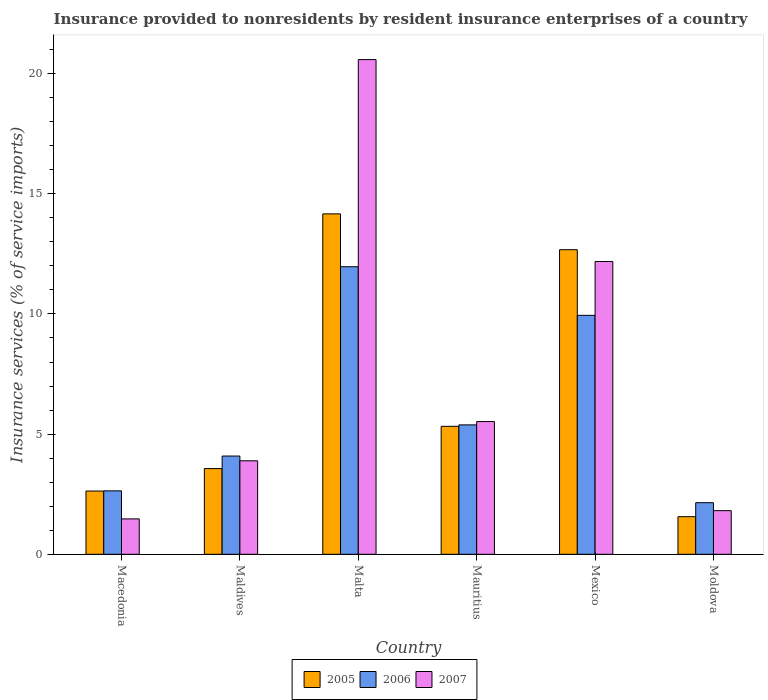How many different coloured bars are there?
Your answer should be compact. 3. Are the number of bars on each tick of the X-axis equal?
Your response must be concise. Yes. How many bars are there on the 4th tick from the left?
Your answer should be compact. 3. What is the label of the 2nd group of bars from the left?
Offer a very short reply. Maldives. In how many cases, is the number of bars for a given country not equal to the number of legend labels?
Provide a succinct answer. 0. What is the insurance provided to nonresidents in 2007 in Maldives?
Offer a very short reply. 3.89. Across all countries, what is the maximum insurance provided to nonresidents in 2007?
Give a very brief answer. 20.58. Across all countries, what is the minimum insurance provided to nonresidents in 2006?
Your answer should be compact. 2.15. In which country was the insurance provided to nonresidents in 2006 maximum?
Offer a very short reply. Malta. In which country was the insurance provided to nonresidents in 2006 minimum?
Offer a very short reply. Moldova. What is the total insurance provided to nonresidents in 2005 in the graph?
Ensure brevity in your answer.  39.92. What is the difference between the insurance provided to nonresidents in 2007 in Maldives and that in Mauritius?
Keep it short and to the point. -1.63. What is the difference between the insurance provided to nonresidents in 2007 in Mauritius and the insurance provided to nonresidents in 2006 in Moldova?
Give a very brief answer. 3.38. What is the average insurance provided to nonresidents in 2005 per country?
Provide a succinct answer. 6.65. What is the difference between the insurance provided to nonresidents of/in 2005 and insurance provided to nonresidents of/in 2007 in Malta?
Offer a terse response. -6.42. In how many countries, is the insurance provided to nonresidents in 2005 greater than 14 %?
Make the answer very short. 1. What is the ratio of the insurance provided to nonresidents in 2005 in Malta to that in Mauritius?
Offer a terse response. 2.66. Is the insurance provided to nonresidents in 2005 in Mauritius less than that in Moldova?
Keep it short and to the point. No. What is the difference between the highest and the second highest insurance provided to nonresidents in 2005?
Your response must be concise. 7.35. What is the difference between the highest and the lowest insurance provided to nonresidents in 2007?
Offer a very short reply. 19.11. In how many countries, is the insurance provided to nonresidents in 2007 greater than the average insurance provided to nonresidents in 2007 taken over all countries?
Provide a short and direct response. 2. Is the sum of the insurance provided to nonresidents in 2005 in Macedonia and Mauritius greater than the maximum insurance provided to nonresidents in 2007 across all countries?
Give a very brief answer. No. What does the 3rd bar from the left in Mexico represents?
Provide a short and direct response. 2007. What does the 2nd bar from the right in Maldives represents?
Your answer should be very brief. 2006. How many countries are there in the graph?
Your answer should be very brief. 6. How are the legend labels stacked?
Your answer should be very brief. Horizontal. What is the title of the graph?
Your response must be concise. Insurance provided to nonresidents by resident insurance enterprises of a country. What is the label or title of the Y-axis?
Provide a succinct answer. Insurance services (% of service imports). What is the Insurance services (% of service imports) of 2005 in Macedonia?
Your answer should be compact. 2.63. What is the Insurance services (% of service imports) in 2006 in Macedonia?
Provide a succinct answer. 2.64. What is the Insurance services (% of service imports) of 2007 in Macedonia?
Provide a succinct answer. 1.47. What is the Insurance services (% of service imports) in 2005 in Maldives?
Provide a succinct answer. 3.57. What is the Insurance services (% of service imports) of 2006 in Maldives?
Give a very brief answer. 4.09. What is the Insurance services (% of service imports) of 2007 in Maldives?
Provide a short and direct response. 3.89. What is the Insurance services (% of service imports) in 2005 in Malta?
Provide a succinct answer. 14.16. What is the Insurance services (% of service imports) in 2006 in Malta?
Offer a terse response. 11.96. What is the Insurance services (% of service imports) of 2007 in Malta?
Keep it short and to the point. 20.58. What is the Insurance services (% of service imports) in 2005 in Mauritius?
Offer a terse response. 5.32. What is the Insurance services (% of service imports) in 2006 in Mauritius?
Offer a very short reply. 5.38. What is the Insurance services (% of service imports) of 2007 in Mauritius?
Provide a short and direct response. 5.52. What is the Insurance services (% of service imports) of 2005 in Mexico?
Your answer should be compact. 12.67. What is the Insurance services (% of service imports) of 2006 in Mexico?
Make the answer very short. 9.94. What is the Insurance services (% of service imports) in 2007 in Mexico?
Give a very brief answer. 12.18. What is the Insurance services (% of service imports) in 2005 in Moldova?
Your answer should be compact. 1.56. What is the Insurance services (% of service imports) of 2006 in Moldova?
Give a very brief answer. 2.15. What is the Insurance services (% of service imports) of 2007 in Moldova?
Your answer should be very brief. 1.82. Across all countries, what is the maximum Insurance services (% of service imports) of 2005?
Offer a very short reply. 14.16. Across all countries, what is the maximum Insurance services (% of service imports) in 2006?
Offer a very short reply. 11.96. Across all countries, what is the maximum Insurance services (% of service imports) of 2007?
Your response must be concise. 20.58. Across all countries, what is the minimum Insurance services (% of service imports) of 2005?
Your answer should be compact. 1.56. Across all countries, what is the minimum Insurance services (% of service imports) of 2006?
Keep it short and to the point. 2.15. Across all countries, what is the minimum Insurance services (% of service imports) of 2007?
Give a very brief answer. 1.47. What is the total Insurance services (% of service imports) in 2005 in the graph?
Your answer should be compact. 39.92. What is the total Insurance services (% of service imports) of 2006 in the graph?
Your answer should be very brief. 36.17. What is the total Insurance services (% of service imports) of 2007 in the graph?
Offer a terse response. 45.47. What is the difference between the Insurance services (% of service imports) in 2005 in Macedonia and that in Maldives?
Provide a short and direct response. -0.93. What is the difference between the Insurance services (% of service imports) of 2006 in Macedonia and that in Maldives?
Offer a very short reply. -1.45. What is the difference between the Insurance services (% of service imports) of 2007 in Macedonia and that in Maldives?
Make the answer very short. -2.42. What is the difference between the Insurance services (% of service imports) of 2005 in Macedonia and that in Malta?
Keep it short and to the point. -11.53. What is the difference between the Insurance services (% of service imports) in 2006 in Macedonia and that in Malta?
Provide a succinct answer. -9.32. What is the difference between the Insurance services (% of service imports) in 2007 in Macedonia and that in Malta?
Your answer should be compact. -19.11. What is the difference between the Insurance services (% of service imports) in 2005 in Macedonia and that in Mauritius?
Give a very brief answer. -2.69. What is the difference between the Insurance services (% of service imports) in 2006 in Macedonia and that in Mauritius?
Provide a short and direct response. -2.74. What is the difference between the Insurance services (% of service imports) of 2007 in Macedonia and that in Mauritius?
Your response must be concise. -4.05. What is the difference between the Insurance services (% of service imports) of 2005 in Macedonia and that in Mexico?
Your answer should be compact. -10.04. What is the difference between the Insurance services (% of service imports) in 2006 in Macedonia and that in Mexico?
Make the answer very short. -7.3. What is the difference between the Insurance services (% of service imports) in 2007 in Macedonia and that in Mexico?
Offer a terse response. -10.71. What is the difference between the Insurance services (% of service imports) in 2005 in Macedonia and that in Moldova?
Offer a very short reply. 1.07. What is the difference between the Insurance services (% of service imports) of 2006 in Macedonia and that in Moldova?
Offer a very short reply. 0.49. What is the difference between the Insurance services (% of service imports) of 2007 in Macedonia and that in Moldova?
Offer a terse response. -0.34. What is the difference between the Insurance services (% of service imports) of 2005 in Maldives and that in Malta?
Ensure brevity in your answer.  -10.6. What is the difference between the Insurance services (% of service imports) of 2006 in Maldives and that in Malta?
Your answer should be very brief. -7.88. What is the difference between the Insurance services (% of service imports) in 2007 in Maldives and that in Malta?
Your response must be concise. -16.69. What is the difference between the Insurance services (% of service imports) of 2005 in Maldives and that in Mauritius?
Keep it short and to the point. -1.76. What is the difference between the Insurance services (% of service imports) in 2006 in Maldives and that in Mauritius?
Your answer should be very brief. -1.3. What is the difference between the Insurance services (% of service imports) of 2007 in Maldives and that in Mauritius?
Give a very brief answer. -1.63. What is the difference between the Insurance services (% of service imports) of 2005 in Maldives and that in Mexico?
Your response must be concise. -9.11. What is the difference between the Insurance services (% of service imports) of 2006 in Maldives and that in Mexico?
Offer a terse response. -5.85. What is the difference between the Insurance services (% of service imports) of 2007 in Maldives and that in Mexico?
Provide a succinct answer. -8.29. What is the difference between the Insurance services (% of service imports) in 2005 in Maldives and that in Moldova?
Offer a very short reply. 2. What is the difference between the Insurance services (% of service imports) in 2006 in Maldives and that in Moldova?
Give a very brief answer. 1.94. What is the difference between the Insurance services (% of service imports) of 2007 in Maldives and that in Moldova?
Your answer should be compact. 2.07. What is the difference between the Insurance services (% of service imports) in 2005 in Malta and that in Mauritius?
Give a very brief answer. 8.84. What is the difference between the Insurance services (% of service imports) of 2006 in Malta and that in Mauritius?
Give a very brief answer. 6.58. What is the difference between the Insurance services (% of service imports) of 2007 in Malta and that in Mauritius?
Offer a very short reply. 15.06. What is the difference between the Insurance services (% of service imports) of 2005 in Malta and that in Mexico?
Make the answer very short. 1.49. What is the difference between the Insurance services (% of service imports) of 2006 in Malta and that in Mexico?
Offer a very short reply. 2.02. What is the difference between the Insurance services (% of service imports) of 2007 in Malta and that in Mexico?
Your response must be concise. 8.4. What is the difference between the Insurance services (% of service imports) of 2005 in Malta and that in Moldova?
Your response must be concise. 12.6. What is the difference between the Insurance services (% of service imports) of 2006 in Malta and that in Moldova?
Ensure brevity in your answer.  9.82. What is the difference between the Insurance services (% of service imports) of 2007 in Malta and that in Moldova?
Ensure brevity in your answer.  18.77. What is the difference between the Insurance services (% of service imports) of 2005 in Mauritius and that in Mexico?
Keep it short and to the point. -7.35. What is the difference between the Insurance services (% of service imports) of 2006 in Mauritius and that in Mexico?
Provide a succinct answer. -4.56. What is the difference between the Insurance services (% of service imports) of 2007 in Mauritius and that in Mexico?
Provide a short and direct response. -6.66. What is the difference between the Insurance services (% of service imports) in 2005 in Mauritius and that in Moldova?
Ensure brevity in your answer.  3.76. What is the difference between the Insurance services (% of service imports) in 2006 in Mauritius and that in Moldova?
Your response must be concise. 3.24. What is the difference between the Insurance services (% of service imports) of 2007 in Mauritius and that in Moldova?
Provide a succinct answer. 3.71. What is the difference between the Insurance services (% of service imports) of 2005 in Mexico and that in Moldova?
Keep it short and to the point. 11.11. What is the difference between the Insurance services (% of service imports) of 2006 in Mexico and that in Moldova?
Your response must be concise. 7.79. What is the difference between the Insurance services (% of service imports) in 2007 in Mexico and that in Moldova?
Make the answer very short. 10.36. What is the difference between the Insurance services (% of service imports) of 2005 in Macedonia and the Insurance services (% of service imports) of 2006 in Maldives?
Offer a terse response. -1.46. What is the difference between the Insurance services (% of service imports) in 2005 in Macedonia and the Insurance services (% of service imports) in 2007 in Maldives?
Keep it short and to the point. -1.26. What is the difference between the Insurance services (% of service imports) in 2006 in Macedonia and the Insurance services (% of service imports) in 2007 in Maldives?
Offer a terse response. -1.25. What is the difference between the Insurance services (% of service imports) of 2005 in Macedonia and the Insurance services (% of service imports) of 2006 in Malta?
Offer a terse response. -9.33. What is the difference between the Insurance services (% of service imports) in 2005 in Macedonia and the Insurance services (% of service imports) in 2007 in Malta?
Make the answer very short. -17.95. What is the difference between the Insurance services (% of service imports) of 2006 in Macedonia and the Insurance services (% of service imports) of 2007 in Malta?
Your answer should be compact. -17.94. What is the difference between the Insurance services (% of service imports) of 2005 in Macedonia and the Insurance services (% of service imports) of 2006 in Mauritius?
Ensure brevity in your answer.  -2.75. What is the difference between the Insurance services (% of service imports) of 2005 in Macedonia and the Insurance services (% of service imports) of 2007 in Mauritius?
Give a very brief answer. -2.89. What is the difference between the Insurance services (% of service imports) of 2006 in Macedonia and the Insurance services (% of service imports) of 2007 in Mauritius?
Your answer should be very brief. -2.88. What is the difference between the Insurance services (% of service imports) in 2005 in Macedonia and the Insurance services (% of service imports) in 2006 in Mexico?
Keep it short and to the point. -7.31. What is the difference between the Insurance services (% of service imports) of 2005 in Macedonia and the Insurance services (% of service imports) of 2007 in Mexico?
Ensure brevity in your answer.  -9.55. What is the difference between the Insurance services (% of service imports) of 2006 in Macedonia and the Insurance services (% of service imports) of 2007 in Mexico?
Your answer should be compact. -9.54. What is the difference between the Insurance services (% of service imports) of 2005 in Macedonia and the Insurance services (% of service imports) of 2006 in Moldova?
Keep it short and to the point. 0.48. What is the difference between the Insurance services (% of service imports) of 2005 in Macedonia and the Insurance services (% of service imports) of 2007 in Moldova?
Ensure brevity in your answer.  0.82. What is the difference between the Insurance services (% of service imports) in 2006 in Macedonia and the Insurance services (% of service imports) in 2007 in Moldova?
Provide a short and direct response. 0.82. What is the difference between the Insurance services (% of service imports) of 2005 in Maldives and the Insurance services (% of service imports) of 2006 in Malta?
Provide a succinct answer. -8.4. What is the difference between the Insurance services (% of service imports) in 2005 in Maldives and the Insurance services (% of service imports) in 2007 in Malta?
Give a very brief answer. -17.02. What is the difference between the Insurance services (% of service imports) in 2006 in Maldives and the Insurance services (% of service imports) in 2007 in Malta?
Provide a short and direct response. -16.49. What is the difference between the Insurance services (% of service imports) of 2005 in Maldives and the Insurance services (% of service imports) of 2006 in Mauritius?
Keep it short and to the point. -1.82. What is the difference between the Insurance services (% of service imports) in 2005 in Maldives and the Insurance services (% of service imports) in 2007 in Mauritius?
Your response must be concise. -1.96. What is the difference between the Insurance services (% of service imports) in 2006 in Maldives and the Insurance services (% of service imports) in 2007 in Mauritius?
Keep it short and to the point. -1.43. What is the difference between the Insurance services (% of service imports) in 2005 in Maldives and the Insurance services (% of service imports) in 2006 in Mexico?
Your answer should be compact. -6.38. What is the difference between the Insurance services (% of service imports) in 2005 in Maldives and the Insurance services (% of service imports) in 2007 in Mexico?
Make the answer very short. -8.62. What is the difference between the Insurance services (% of service imports) in 2006 in Maldives and the Insurance services (% of service imports) in 2007 in Mexico?
Provide a succinct answer. -8.09. What is the difference between the Insurance services (% of service imports) of 2005 in Maldives and the Insurance services (% of service imports) of 2006 in Moldova?
Provide a succinct answer. 1.42. What is the difference between the Insurance services (% of service imports) in 2005 in Maldives and the Insurance services (% of service imports) in 2007 in Moldova?
Ensure brevity in your answer.  1.75. What is the difference between the Insurance services (% of service imports) in 2006 in Maldives and the Insurance services (% of service imports) in 2007 in Moldova?
Your response must be concise. 2.27. What is the difference between the Insurance services (% of service imports) in 2005 in Malta and the Insurance services (% of service imports) in 2006 in Mauritius?
Ensure brevity in your answer.  8.78. What is the difference between the Insurance services (% of service imports) in 2005 in Malta and the Insurance services (% of service imports) in 2007 in Mauritius?
Ensure brevity in your answer.  8.64. What is the difference between the Insurance services (% of service imports) of 2006 in Malta and the Insurance services (% of service imports) of 2007 in Mauritius?
Give a very brief answer. 6.44. What is the difference between the Insurance services (% of service imports) of 2005 in Malta and the Insurance services (% of service imports) of 2006 in Mexico?
Your response must be concise. 4.22. What is the difference between the Insurance services (% of service imports) in 2005 in Malta and the Insurance services (% of service imports) in 2007 in Mexico?
Your answer should be compact. 1.98. What is the difference between the Insurance services (% of service imports) in 2006 in Malta and the Insurance services (% of service imports) in 2007 in Mexico?
Keep it short and to the point. -0.22. What is the difference between the Insurance services (% of service imports) of 2005 in Malta and the Insurance services (% of service imports) of 2006 in Moldova?
Give a very brief answer. 12.02. What is the difference between the Insurance services (% of service imports) of 2005 in Malta and the Insurance services (% of service imports) of 2007 in Moldova?
Provide a succinct answer. 12.35. What is the difference between the Insurance services (% of service imports) of 2006 in Malta and the Insurance services (% of service imports) of 2007 in Moldova?
Provide a short and direct response. 10.15. What is the difference between the Insurance services (% of service imports) of 2005 in Mauritius and the Insurance services (% of service imports) of 2006 in Mexico?
Offer a very short reply. -4.62. What is the difference between the Insurance services (% of service imports) in 2005 in Mauritius and the Insurance services (% of service imports) in 2007 in Mexico?
Offer a very short reply. -6.86. What is the difference between the Insurance services (% of service imports) in 2006 in Mauritius and the Insurance services (% of service imports) in 2007 in Mexico?
Offer a terse response. -6.8. What is the difference between the Insurance services (% of service imports) of 2005 in Mauritius and the Insurance services (% of service imports) of 2006 in Moldova?
Your answer should be very brief. 3.18. What is the difference between the Insurance services (% of service imports) of 2005 in Mauritius and the Insurance services (% of service imports) of 2007 in Moldova?
Your answer should be very brief. 3.51. What is the difference between the Insurance services (% of service imports) of 2006 in Mauritius and the Insurance services (% of service imports) of 2007 in Moldova?
Your response must be concise. 3.57. What is the difference between the Insurance services (% of service imports) of 2005 in Mexico and the Insurance services (% of service imports) of 2006 in Moldova?
Your answer should be very brief. 10.53. What is the difference between the Insurance services (% of service imports) of 2005 in Mexico and the Insurance services (% of service imports) of 2007 in Moldova?
Your response must be concise. 10.86. What is the difference between the Insurance services (% of service imports) of 2006 in Mexico and the Insurance services (% of service imports) of 2007 in Moldova?
Ensure brevity in your answer.  8.13. What is the average Insurance services (% of service imports) in 2005 per country?
Make the answer very short. 6.65. What is the average Insurance services (% of service imports) of 2006 per country?
Give a very brief answer. 6.03. What is the average Insurance services (% of service imports) in 2007 per country?
Give a very brief answer. 7.58. What is the difference between the Insurance services (% of service imports) of 2005 and Insurance services (% of service imports) of 2006 in Macedonia?
Offer a terse response. -0.01. What is the difference between the Insurance services (% of service imports) in 2005 and Insurance services (% of service imports) in 2007 in Macedonia?
Your response must be concise. 1.16. What is the difference between the Insurance services (% of service imports) in 2006 and Insurance services (% of service imports) in 2007 in Macedonia?
Your answer should be very brief. 1.17. What is the difference between the Insurance services (% of service imports) of 2005 and Insurance services (% of service imports) of 2006 in Maldives?
Offer a very short reply. -0.52. What is the difference between the Insurance services (% of service imports) in 2005 and Insurance services (% of service imports) in 2007 in Maldives?
Your answer should be compact. -0.33. What is the difference between the Insurance services (% of service imports) in 2006 and Insurance services (% of service imports) in 2007 in Maldives?
Keep it short and to the point. 0.2. What is the difference between the Insurance services (% of service imports) in 2005 and Insurance services (% of service imports) in 2006 in Malta?
Offer a terse response. 2.2. What is the difference between the Insurance services (% of service imports) of 2005 and Insurance services (% of service imports) of 2007 in Malta?
Your response must be concise. -6.42. What is the difference between the Insurance services (% of service imports) of 2006 and Insurance services (% of service imports) of 2007 in Malta?
Offer a very short reply. -8.62. What is the difference between the Insurance services (% of service imports) in 2005 and Insurance services (% of service imports) in 2006 in Mauritius?
Your answer should be compact. -0.06. What is the difference between the Insurance services (% of service imports) of 2005 and Insurance services (% of service imports) of 2007 in Mauritius?
Your answer should be very brief. -0.2. What is the difference between the Insurance services (% of service imports) of 2006 and Insurance services (% of service imports) of 2007 in Mauritius?
Provide a short and direct response. -0.14. What is the difference between the Insurance services (% of service imports) of 2005 and Insurance services (% of service imports) of 2006 in Mexico?
Ensure brevity in your answer.  2.73. What is the difference between the Insurance services (% of service imports) of 2005 and Insurance services (% of service imports) of 2007 in Mexico?
Provide a succinct answer. 0.49. What is the difference between the Insurance services (% of service imports) in 2006 and Insurance services (% of service imports) in 2007 in Mexico?
Ensure brevity in your answer.  -2.24. What is the difference between the Insurance services (% of service imports) of 2005 and Insurance services (% of service imports) of 2006 in Moldova?
Your answer should be compact. -0.58. What is the difference between the Insurance services (% of service imports) in 2005 and Insurance services (% of service imports) in 2007 in Moldova?
Your answer should be very brief. -0.25. What is the difference between the Insurance services (% of service imports) of 2006 and Insurance services (% of service imports) of 2007 in Moldova?
Offer a terse response. 0.33. What is the ratio of the Insurance services (% of service imports) in 2005 in Macedonia to that in Maldives?
Make the answer very short. 0.74. What is the ratio of the Insurance services (% of service imports) of 2006 in Macedonia to that in Maldives?
Give a very brief answer. 0.65. What is the ratio of the Insurance services (% of service imports) in 2007 in Macedonia to that in Maldives?
Your answer should be compact. 0.38. What is the ratio of the Insurance services (% of service imports) in 2005 in Macedonia to that in Malta?
Your answer should be very brief. 0.19. What is the ratio of the Insurance services (% of service imports) in 2006 in Macedonia to that in Malta?
Provide a short and direct response. 0.22. What is the ratio of the Insurance services (% of service imports) of 2007 in Macedonia to that in Malta?
Your answer should be compact. 0.07. What is the ratio of the Insurance services (% of service imports) of 2005 in Macedonia to that in Mauritius?
Make the answer very short. 0.49. What is the ratio of the Insurance services (% of service imports) in 2006 in Macedonia to that in Mauritius?
Your answer should be compact. 0.49. What is the ratio of the Insurance services (% of service imports) in 2007 in Macedonia to that in Mauritius?
Your answer should be very brief. 0.27. What is the ratio of the Insurance services (% of service imports) in 2005 in Macedonia to that in Mexico?
Your answer should be compact. 0.21. What is the ratio of the Insurance services (% of service imports) in 2006 in Macedonia to that in Mexico?
Offer a terse response. 0.27. What is the ratio of the Insurance services (% of service imports) of 2007 in Macedonia to that in Mexico?
Make the answer very short. 0.12. What is the ratio of the Insurance services (% of service imports) in 2005 in Macedonia to that in Moldova?
Offer a terse response. 1.68. What is the ratio of the Insurance services (% of service imports) in 2006 in Macedonia to that in Moldova?
Ensure brevity in your answer.  1.23. What is the ratio of the Insurance services (% of service imports) of 2007 in Macedonia to that in Moldova?
Your answer should be very brief. 0.81. What is the ratio of the Insurance services (% of service imports) of 2005 in Maldives to that in Malta?
Your response must be concise. 0.25. What is the ratio of the Insurance services (% of service imports) in 2006 in Maldives to that in Malta?
Offer a very short reply. 0.34. What is the ratio of the Insurance services (% of service imports) in 2007 in Maldives to that in Malta?
Offer a very short reply. 0.19. What is the ratio of the Insurance services (% of service imports) of 2005 in Maldives to that in Mauritius?
Provide a short and direct response. 0.67. What is the ratio of the Insurance services (% of service imports) of 2006 in Maldives to that in Mauritius?
Your answer should be very brief. 0.76. What is the ratio of the Insurance services (% of service imports) of 2007 in Maldives to that in Mauritius?
Make the answer very short. 0.7. What is the ratio of the Insurance services (% of service imports) in 2005 in Maldives to that in Mexico?
Ensure brevity in your answer.  0.28. What is the ratio of the Insurance services (% of service imports) of 2006 in Maldives to that in Mexico?
Your answer should be compact. 0.41. What is the ratio of the Insurance services (% of service imports) in 2007 in Maldives to that in Mexico?
Offer a very short reply. 0.32. What is the ratio of the Insurance services (% of service imports) of 2005 in Maldives to that in Moldova?
Provide a succinct answer. 2.28. What is the ratio of the Insurance services (% of service imports) of 2006 in Maldives to that in Moldova?
Make the answer very short. 1.9. What is the ratio of the Insurance services (% of service imports) in 2007 in Maldives to that in Moldova?
Offer a very short reply. 2.14. What is the ratio of the Insurance services (% of service imports) in 2005 in Malta to that in Mauritius?
Keep it short and to the point. 2.66. What is the ratio of the Insurance services (% of service imports) of 2006 in Malta to that in Mauritius?
Your answer should be compact. 2.22. What is the ratio of the Insurance services (% of service imports) in 2007 in Malta to that in Mauritius?
Provide a short and direct response. 3.73. What is the ratio of the Insurance services (% of service imports) of 2005 in Malta to that in Mexico?
Keep it short and to the point. 1.12. What is the ratio of the Insurance services (% of service imports) in 2006 in Malta to that in Mexico?
Your response must be concise. 1.2. What is the ratio of the Insurance services (% of service imports) of 2007 in Malta to that in Mexico?
Your response must be concise. 1.69. What is the ratio of the Insurance services (% of service imports) of 2005 in Malta to that in Moldova?
Provide a succinct answer. 9.05. What is the ratio of the Insurance services (% of service imports) in 2006 in Malta to that in Moldova?
Offer a terse response. 5.57. What is the ratio of the Insurance services (% of service imports) of 2007 in Malta to that in Moldova?
Ensure brevity in your answer.  11.33. What is the ratio of the Insurance services (% of service imports) of 2005 in Mauritius to that in Mexico?
Your answer should be very brief. 0.42. What is the ratio of the Insurance services (% of service imports) of 2006 in Mauritius to that in Mexico?
Your response must be concise. 0.54. What is the ratio of the Insurance services (% of service imports) in 2007 in Mauritius to that in Mexico?
Provide a succinct answer. 0.45. What is the ratio of the Insurance services (% of service imports) in 2005 in Mauritius to that in Moldova?
Provide a succinct answer. 3.4. What is the ratio of the Insurance services (% of service imports) in 2006 in Mauritius to that in Moldova?
Keep it short and to the point. 2.51. What is the ratio of the Insurance services (% of service imports) in 2007 in Mauritius to that in Moldova?
Give a very brief answer. 3.04. What is the ratio of the Insurance services (% of service imports) in 2005 in Mexico to that in Moldova?
Offer a terse response. 8.1. What is the ratio of the Insurance services (% of service imports) in 2006 in Mexico to that in Moldova?
Provide a short and direct response. 4.63. What is the ratio of the Insurance services (% of service imports) of 2007 in Mexico to that in Moldova?
Your response must be concise. 6.71. What is the difference between the highest and the second highest Insurance services (% of service imports) in 2005?
Ensure brevity in your answer.  1.49. What is the difference between the highest and the second highest Insurance services (% of service imports) of 2006?
Your answer should be very brief. 2.02. What is the difference between the highest and the second highest Insurance services (% of service imports) of 2007?
Make the answer very short. 8.4. What is the difference between the highest and the lowest Insurance services (% of service imports) in 2005?
Your answer should be compact. 12.6. What is the difference between the highest and the lowest Insurance services (% of service imports) in 2006?
Provide a short and direct response. 9.82. What is the difference between the highest and the lowest Insurance services (% of service imports) of 2007?
Provide a succinct answer. 19.11. 